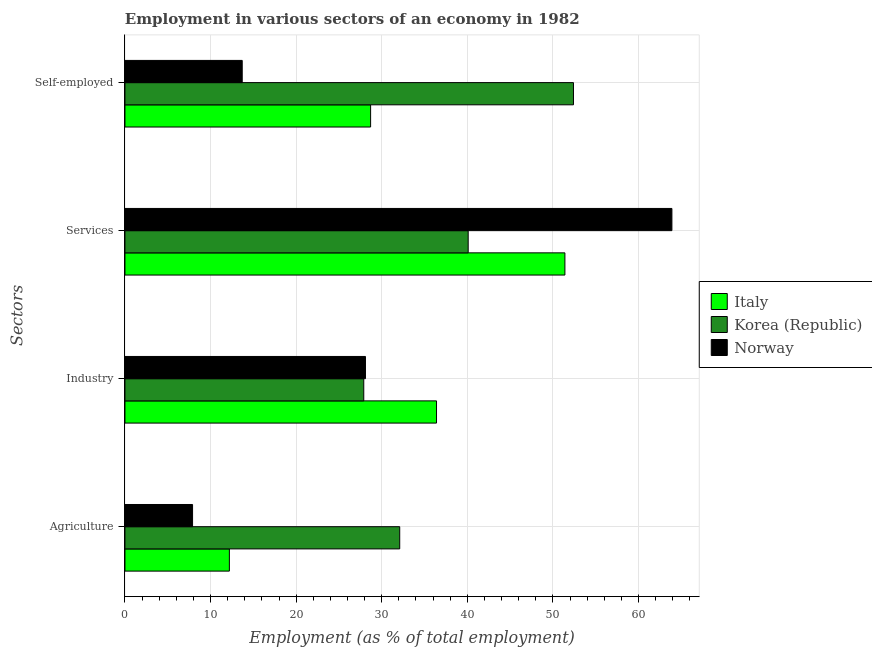How many different coloured bars are there?
Make the answer very short. 3. Are the number of bars per tick equal to the number of legend labels?
Your answer should be compact. Yes. Are the number of bars on each tick of the Y-axis equal?
Offer a terse response. Yes. How many bars are there on the 1st tick from the top?
Offer a terse response. 3. What is the label of the 4th group of bars from the top?
Keep it short and to the point. Agriculture. What is the percentage of workers in industry in Korea (Republic)?
Provide a short and direct response. 27.9. Across all countries, what is the maximum percentage of workers in industry?
Offer a terse response. 36.4. Across all countries, what is the minimum percentage of workers in services?
Your response must be concise. 40.1. What is the total percentage of workers in services in the graph?
Ensure brevity in your answer.  155.4. What is the difference between the percentage of workers in agriculture in Korea (Republic) and that in Norway?
Give a very brief answer. 24.2. What is the difference between the percentage of workers in agriculture in Italy and the percentage of self employed workers in Korea (Republic)?
Keep it short and to the point. -40.2. What is the average percentage of workers in agriculture per country?
Your response must be concise. 17.4. What is the difference between the percentage of self employed workers and percentage of workers in industry in Norway?
Make the answer very short. -14.4. What is the ratio of the percentage of workers in agriculture in Norway to that in Italy?
Your answer should be compact. 0.65. Is the percentage of workers in industry in Korea (Republic) less than that in Italy?
Provide a short and direct response. Yes. Is the difference between the percentage of workers in agriculture in Italy and Korea (Republic) greater than the difference between the percentage of workers in services in Italy and Korea (Republic)?
Give a very brief answer. No. What is the difference between the highest and the second highest percentage of workers in services?
Your answer should be very brief. 12.5. What is the difference between the highest and the lowest percentage of workers in industry?
Provide a succinct answer. 8.5. Is it the case that in every country, the sum of the percentage of workers in agriculture and percentage of workers in industry is greater than the sum of percentage of workers in services and percentage of self employed workers?
Your response must be concise. No. What does the 2nd bar from the top in Services represents?
Give a very brief answer. Korea (Republic). How many countries are there in the graph?
Provide a short and direct response. 3. Does the graph contain grids?
Your response must be concise. Yes. How many legend labels are there?
Provide a succinct answer. 3. How are the legend labels stacked?
Provide a succinct answer. Vertical. What is the title of the graph?
Your answer should be compact. Employment in various sectors of an economy in 1982. What is the label or title of the X-axis?
Your response must be concise. Employment (as % of total employment). What is the label or title of the Y-axis?
Make the answer very short. Sectors. What is the Employment (as % of total employment) in Italy in Agriculture?
Keep it short and to the point. 12.2. What is the Employment (as % of total employment) of Korea (Republic) in Agriculture?
Your answer should be very brief. 32.1. What is the Employment (as % of total employment) in Norway in Agriculture?
Ensure brevity in your answer.  7.9. What is the Employment (as % of total employment) in Italy in Industry?
Your answer should be compact. 36.4. What is the Employment (as % of total employment) in Korea (Republic) in Industry?
Offer a terse response. 27.9. What is the Employment (as % of total employment) in Norway in Industry?
Offer a terse response. 28.1. What is the Employment (as % of total employment) in Italy in Services?
Your response must be concise. 51.4. What is the Employment (as % of total employment) in Korea (Republic) in Services?
Your response must be concise. 40.1. What is the Employment (as % of total employment) in Norway in Services?
Keep it short and to the point. 63.9. What is the Employment (as % of total employment) of Italy in Self-employed?
Ensure brevity in your answer.  28.7. What is the Employment (as % of total employment) of Korea (Republic) in Self-employed?
Keep it short and to the point. 52.4. What is the Employment (as % of total employment) of Norway in Self-employed?
Provide a short and direct response. 13.7. Across all Sectors, what is the maximum Employment (as % of total employment) of Italy?
Make the answer very short. 51.4. Across all Sectors, what is the maximum Employment (as % of total employment) of Korea (Republic)?
Ensure brevity in your answer.  52.4. Across all Sectors, what is the maximum Employment (as % of total employment) of Norway?
Provide a succinct answer. 63.9. Across all Sectors, what is the minimum Employment (as % of total employment) in Italy?
Provide a short and direct response. 12.2. Across all Sectors, what is the minimum Employment (as % of total employment) in Korea (Republic)?
Offer a very short reply. 27.9. Across all Sectors, what is the minimum Employment (as % of total employment) of Norway?
Your answer should be very brief. 7.9. What is the total Employment (as % of total employment) of Italy in the graph?
Your response must be concise. 128.7. What is the total Employment (as % of total employment) of Korea (Republic) in the graph?
Provide a short and direct response. 152.5. What is the total Employment (as % of total employment) of Norway in the graph?
Offer a very short reply. 113.6. What is the difference between the Employment (as % of total employment) in Italy in Agriculture and that in Industry?
Your response must be concise. -24.2. What is the difference between the Employment (as % of total employment) in Norway in Agriculture and that in Industry?
Give a very brief answer. -20.2. What is the difference between the Employment (as % of total employment) of Italy in Agriculture and that in Services?
Ensure brevity in your answer.  -39.2. What is the difference between the Employment (as % of total employment) of Norway in Agriculture and that in Services?
Your response must be concise. -56. What is the difference between the Employment (as % of total employment) in Italy in Agriculture and that in Self-employed?
Your answer should be very brief. -16.5. What is the difference between the Employment (as % of total employment) in Korea (Republic) in Agriculture and that in Self-employed?
Offer a very short reply. -20.3. What is the difference between the Employment (as % of total employment) in Norway in Agriculture and that in Self-employed?
Make the answer very short. -5.8. What is the difference between the Employment (as % of total employment) in Norway in Industry and that in Services?
Your answer should be compact. -35.8. What is the difference between the Employment (as % of total employment) in Italy in Industry and that in Self-employed?
Offer a terse response. 7.7. What is the difference between the Employment (as % of total employment) in Korea (Republic) in Industry and that in Self-employed?
Keep it short and to the point. -24.5. What is the difference between the Employment (as % of total employment) in Italy in Services and that in Self-employed?
Your answer should be very brief. 22.7. What is the difference between the Employment (as % of total employment) of Korea (Republic) in Services and that in Self-employed?
Make the answer very short. -12.3. What is the difference between the Employment (as % of total employment) of Norway in Services and that in Self-employed?
Your response must be concise. 50.2. What is the difference between the Employment (as % of total employment) in Italy in Agriculture and the Employment (as % of total employment) in Korea (Republic) in Industry?
Keep it short and to the point. -15.7. What is the difference between the Employment (as % of total employment) of Italy in Agriculture and the Employment (as % of total employment) of Norway in Industry?
Provide a succinct answer. -15.9. What is the difference between the Employment (as % of total employment) of Italy in Agriculture and the Employment (as % of total employment) of Korea (Republic) in Services?
Provide a succinct answer. -27.9. What is the difference between the Employment (as % of total employment) in Italy in Agriculture and the Employment (as % of total employment) in Norway in Services?
Your answer should be compact. -51.7. What is the difference between the Employment (as % of total employment) of Korea (Republic) in Agriculture and the Employment (as % of total employment) of Norway in Services?
Make the answer very short. -31.8. What is the difference between the Employment (as % of total employment) in Italy in Agriculture and the Employment (as % of total employment) in Korea (Republic) in Self-employed?
Your answer should be compact. -40.2. What is the difference between the Employment (as % of total employment) in Italy in Agriculture and the Employment (as % of total employment) in Norway in Self-employed?
Provide a succinct answer. -1.5. What is the difference between the Employment (as % of total employment) of Korea (Republic) in Agriculture and the Employment (as % of total employment) of Norway in Self-employed?
Make the answer very short. 18.4. What is the difference between the Employment (as % of total employment) in Italy in Industry and the Employment (as % of total employment) in Korea (Republic) in Services?
Provide a short and direct response. -3.7. What is the difference between the Employment (as % of total employment) of Italy in Industry and the Employment (as % of total employment) of Norway in Services?
Offer a terse response. -27.5. What is the difference between the Employment (as % of total employment) of Korea (Republic) in Industry and the Employment (as % of total employment) of Norway in Services?
Ensure brevity in your answer.  -36. What is the difference between the Employment (as % of total employment) in Italy in Industry and the Employment (as % of total employment) in Norway in Self-employed?
Offer a terse response. 22.7. What is the difference between the Employment (as % of total employment) in Italy in Services and the Employment (as % of total employment) in Korea (Republic) in Self-employed?
Your answer should be very brief. -1. What is the difference between the Employment (as % of total employment) in Italy in Services and the Employment (as % of total employment) in Norway in Self-employed?
Make the answer very short. 37.7. What is the difference between the Employment (as % of total employment) of Korea (Republic) in Services and the Employment (as % of total employment) of Norway in Self-employed?
Offer a terse response. 26.4. What is the average Employment (as % of total employment) of Italy per Sectors?
Your response must be concise. 32.17. What is the average Employment (as % of total employment) of Korea (Republic) per Sectors?
Offer a terse response. 38.12. What is the average Employment (as % of total employment) in Norway per Sectors?
Give a very brief answer. 28.4. What is the difference between the Employment (as % of total employment) of Italy and Employment (as % of total employment) of Korea (Republic) in Agriculture?
Provide a short and direct response. -19.9. What is the difference between the Employment (as % of total employment) of Italy and Employment (as % of total employment) of Norway in Agriculture?
Provide a short and direct response. 4.3. What is the difference between the Employment (as % of total employment) in Korea (Republic) and Employment (as % of total employment) in Norway in Agriculture?
Your answer should be very brief. 24.2. What is the difference between the Employment (as % of total employment) in Italy and Employment (as % of total employment) in Korea (Republic) in Services?
Provide a short and direct response. 11.3. What is the difference between the Employment (as % of total employment) of Italy and Employment (as % of total employment) of Norway in Services?
Your answer should be compact. -12.5. What is the difference between the Employment (as % of total employment) in Korea (Republic) and Employment (as % of total employment) in Norway in Services?
Ensure brevity in your answer.  -23.8. What is the difference between the Employment (as % of total employment) of Italy and Employment (as % of total employment) of Korea (Republic) in Self-employed?
Offer a terse response. -23.7. What is the difference between the Employment (as % of total employment) of Korea (Republic) and Employment (as % of total employment) of Norway in Self-employed?
Keep it short and to the point. 38.7. What is the ratio of the Employment (as % of total employment) of Italy in Agriculture to that in Industry?
Your answer should be compact. 0.34. What is the ratio of the Employment (as % of total employment) in Korea (Republic) in Agriculture to that in Industry?
Your answer should be compact. 1.15. What is the ratio of the Employment (as % of total employment) in Norway in Agriculture to that in Industry?
Offer a very short reply. 0.28. What is the ratio of the Employment (as % of total employment) of Italy in Agriculture to that in Services?
Your answer should be very brief. 0.24. What is the ratio of the Employment (as % of total employment) of Korea (Republic) in Agriculture to that in Services?
Provide a succinct answer. 0.8. What is the ratio of the Employment (as % of total employment) in Norway in Agriculture to that in Services?
Offer a very short reply. 0.12. What is the ratio of the Employment (as % of total employment) in Italy in Agriculture to that in Self-employed?
Your response must be concise. 0.43. What is the ratio of the Employment (as % of total employment) in Korea (Republic) in Agriculture to that in Self-employed?
Your answer should be very brief. 0.61. What is the ratio of the Employment (as % of total employment) in Norway in Agriculture to that in Self-employed?
Your answer should be compact. 0.58. What is the ratio of the Employment (as % of total employment) in Italy in Industry to that in Services?
Provide a succinct answer. 0.71. What is the ratio of the Employment (as % of total employment) of Korea (Republic) in Industry to that in Services?
Offer a terse response. 0.7. What is the ratio of the Employment (as % of total employment) of Norway in Industry to that in Services?
Your answer should be compact. 0.44. What is the ratio of the Employment (as % of total employment) of Italy in Industry to that in Self-employed?
Your answer should be compact. 1.27. What is the ratio of the Employment (as % of total employment) in Korea (Republic) in Industry to that in Self-employed?
Offer a very short reply. 0.53. What is the ratio of the Employment (as % of total employment) of Norway in Industry to that in Self-employed?
Offer a very short reply. 2.05. What is the ratio of the Employment (as % of total employment) in Italy in Services to that in Self-employed?
Make the answer very short. 1.79. What is the ratio of the Employment (as % of total employment) of Korea (Republic) in Services to that in Self-employed?
Your answer should be compact. 0.77. What is the ratio of the Employment (as % of total employment) in Norway in Services to that in Self-employed?
Provide a short and direct response. 4.66. What is the difference between the highest and the second highest Employment (as % of total employment) in Korea (Republic)?
Your answer should be very brief. 12.3. What is the difference between the highest and the second highest Employment (as % of total employment) in Norway?
Your answer should be very brief. 35.8. What is the difference between the highest and the lowest Employment (as % of total employment) in Italy?
Provide a short and direct response. 39.2. 